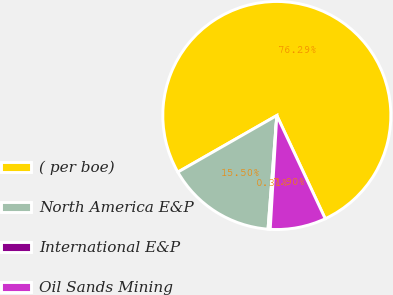Convert chart to OTSL. <chart><loc_0><loc_0><loc_500><loc_500><pie_chart><fcel>( per boe)<fcel>North America E&P<fcel>International E&P<fcel>Oil Sands Mining<nl><fcel>76.29%<fcel>15.5%<fcel>0.31%<fcel>7.9%<nl></chart> 